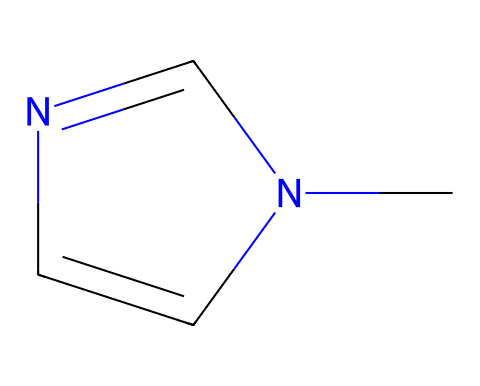What is the name of this chemical? The SMILES representation shows the structure of a compound that includes a nitrogen-containing ring structure with a carbene center. Analyzing the structure, it is recognized as a type of N-heterocyclic carbene.
Answer: N-heterocyclic carbene How many nitrogen atoms are in the structure? The SMILES representation includes the bonds and atoms present in the chemical. Counting from the structure, there are two nitrogen atoms visible in the ring and one attached to a carbon.
Answer: 2 What type of heterocycle is present in this compound? By observing the structure, we see that it contains a five-membered ring with nitrogen atoms, which characterizes it as a pyridine or imidazole derivative based on the connectivity. This is typical for N-heterocyclic carbenes.
Answer: imidazole What is the hybridization of the carbon atom adjacent to the nitrogen atom? Looking at the carbon atom that is attached directly to the nitrogen within the ring, we can identify its molecular geometry. Since it is involved in double bonds and forms a planar structure, it is sp² hybridized.
Answer: sp² How many total bonds are formed around the carbene carbon? Reviewing the structure of the carbene, we note that it has a single bond to one nitrogen atom and a double bond to another nitrogen atom, indicating a total of 2 bonds formed around the carbene carbon.
Answer: 2 